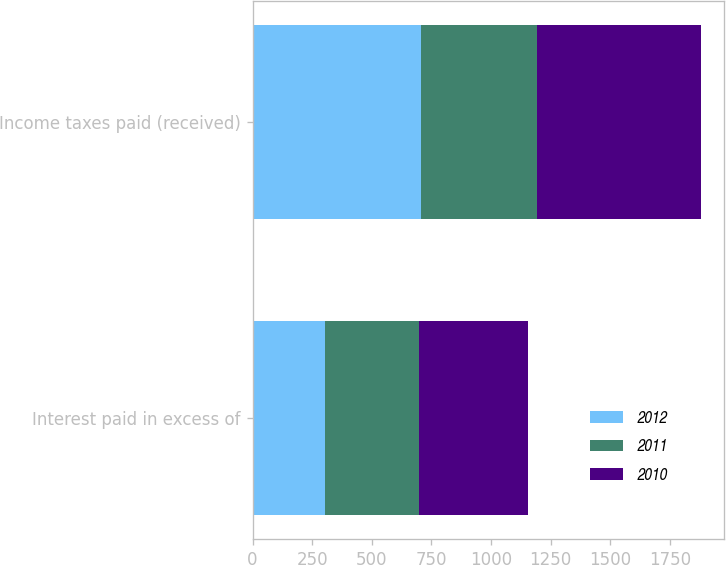Convert chart. <chart><loc_0><loc_0><loc_500><loc_500><stacked_bar_chart><ecel><fcel>Interest paid in excess of<fcel>Income taxes paid (received)<nl><fcel>2012<fcel>302<fcel>705<nl><fcel>2011<fcel>397<fcel>486<nl><fcel>2010<fcel>457<fcel>690<nl></chart> 